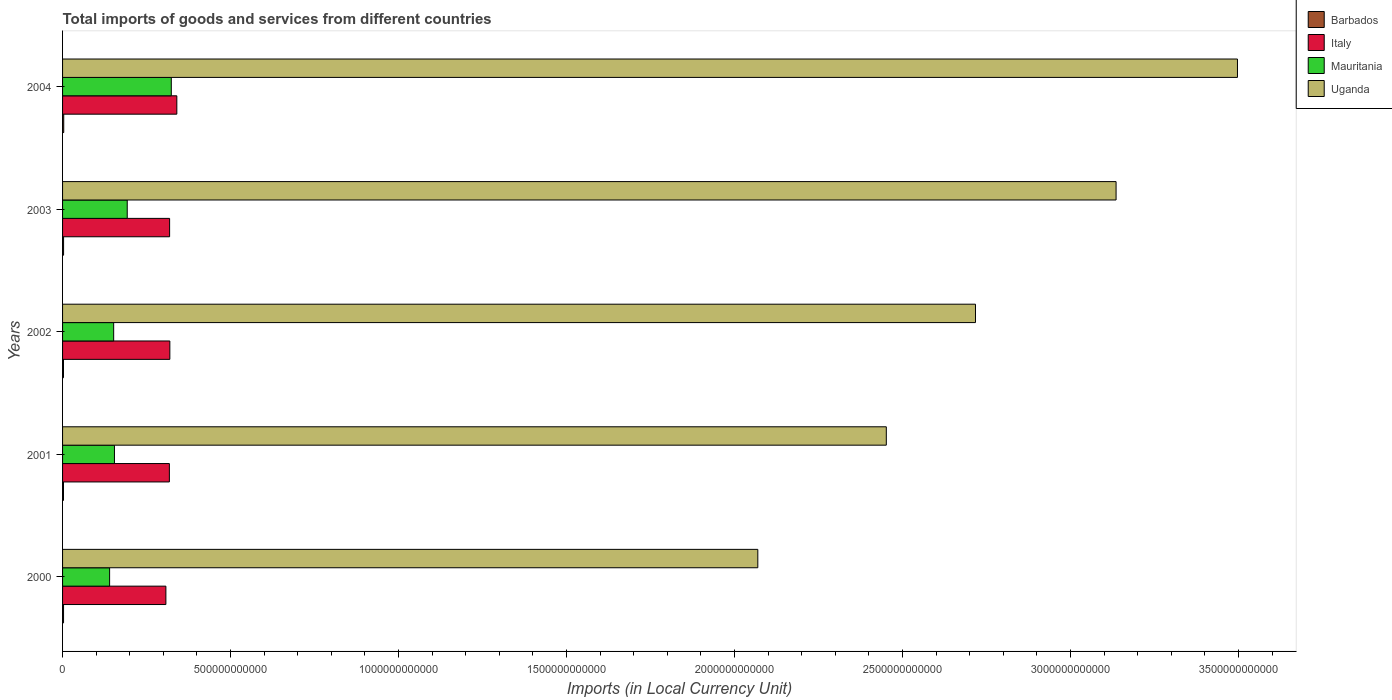Are the number of bars on each tick of the Y-axis equal?
Offer a very short reply. Yes. How many bars are there on the 3rd tick from the top?
Your response must be concise. 4. How many bars are there on the 5th tick from the bottom?
Your response must be concise. 4. What is the Amount of goods and services imports in Mauritania in 2004?
Ensure brevity in your answer.  3.24e+11. Across all years, what is the maximum Amount of goods and services imports in Italy?
Keep it short and to the point. 3.40e+11. Across all years, what is the minimum Amount of goods and services imports in Uganda?
Your answer should be very brief. 2.07e+12. In which year was the Amount of goods and services imports in Uganda minimum?
Provide a succinct answer. 2000. What is the total Amount of goods and services imports in Mauritania in the graph?
Ensure brevity in your answer.  9.63e+11. What is the difference between the Amount of goods and services imports in Mauritania in 2003 and that in 2004?
Provide a short and direct response. -1.31e+11. What is the difference between the Amount of goods and services imports in Barbados in 2004 and the Amount of goods and services imports in Mauritania in 2001?
Offer a terse response. -1.51e+11. What is the average Amount of goods and services imports in Uganda per year?
Offer a terse response. 2.77e+12. In the year 2001, what is the difference between the Amount of goods and services imports in Barbados and Amount of goods and services imports in Italy?
Ensure brevity in your answer.  -3.15e+11. What is the ratio of the Amount of goods and services imports in Uganda in 2002 to that in 2004?
Provide a short and direct response. 0.78. Is the difference between the Amount of goods and services imports in Barbados in 2002 and 2003 greater than the difference between the Amount of goods and services imports in Italy in 2002 and 2003?
Your response must be concise. No. What is the difference between the highest and the second highest Amount of goods and services imports in Mauritania?
Your answer should be compact. 1.31e+11. What is the difference between the highest and the lowest Amount of goods and services imports in Uganda?
Your answer should be compact. 1.43e+12. What does the 4th bar from the top in 2001 represents?
Your answer should be very brief. Barbados. What does the 1st bar from the bottom in 2000 represents?
Your answer should be compact. Barbados. How many years are there in the graph?
Offer a very short reply. 5. What is the difference between two consecutive major ticks on the X-axis?
Keep it short and to the point. 5.00e+11. Does the graph contain any zero values?
Your response must be concise. No. How are the legend labels stacked?
Your answer should be compact. Vertical. What is the title of the graph?
Keep it short and to the point. Total imports of goods and services from different countries. What is the label or title of the X-axis?
Keep it short and to the point. Imports (in Local Currency Unit). What is the Imports (in Local Currency Unit) of Barbados in 2000?
Offer a terse response. 2.90e+09. What is the Imports (in Local Currency Unit) in Italy in 2000?
Ensure brevity in your answer.  3.08e+11. What is the Imports (in Local Currency Unit) in Mauritania in 2000?
Your answer should be compact. 1.40e+11. What is the Imports (in Local Currency Unit) in Uganda in 2000?
Offer a very short reply. 2.07e+12. What is the Imports (in Local Currency Unit) in Barbados in 2001?
Offer a terse response. 2.77e+09. What is the Imports (in Local Currency Unit) of Italy in 2001?
Give a very brief answer. 3.18e+11. What is the Imports (in Local Currency Unit) in Mauritania in 2001?
Offer a very short reply. 1.54e+11. What is the Imports (in Local Currency Unit) in Uganda in 2001?
Your answer should be compact. 2.45e+12. What is the Imports (in Local Currency Unit) of Barbados in 2002?
Offer a terse response. 2.76e+09. What is the Imports (in Local Currency Unit) in Italy in 2002?
Make the answer very short. 3.19e+11. What is the Imports (in Local Currency Unit) in Mauritania in 2002?
Keep it short and to the point. 1.52e+11. What is the Imports (in Local Currency Unit) of Uganda in 2002?
Ensure brevity in your answer.  2.72e+12. What is the Imports (in Local Currency Unit) in Barbados in 2003?
Keep it short and to the point. 3.03e+09. What is the Imports (in Local Currency Unit) of Italy in 2003?
Your response must be concise. 3.19e+11. What is the Imports (in Local Currency Unit) of Mauritania in 2003?
Give a very brief answer. 1.92e+11. What is the Imports (in Local Currency Unit) of Uganda in 2003?
Ensure brevity in your answer.  3.14e+12. What is the Imports (in Local Currency Unit) of Barbados in 2004?
Give a very brief answer. 3.47e+09. What is the Imports (in Local Currency Unit) in Italy in 2004?
Keep it short and to the point. 3.40e+11. What is the Imports (in Local Currency Unit) of Mauritania in 2004?
Provide a short and direct response. 3.24e+11. What is the Imports (in Local Currency Unit) of Uganda in 2004?
Your answer should be compact. 3.50e+12. Across all years, what is the maximum Imports (in Local Currency Unit) of Barbados?
Offer a very short reply. 3.47e+09. Across all years, what is the maximum Imports (in Local Currency Unit) in Italy?
Your response must be concise. 3.40e+11. Across all years, what is the maximum Imports (in Local Currency Unit) in Mauritania?
Give a very brief answer. 3.24e+11. Across all years, what is the maximum Imports (in Local Currency Unit) in Uganda?
Make the answer very short. 3.50e+12. Across all years, what is the minimum Imports (in Local Currency Unit) of Barbados?
Your answer should be compact. 2.76e+09. Across all years, what is the minimum Imports (in Local Currency Unit) in Italy?
Provide a short and direct response. 3.08e+11. Across all years, what is the minimum Imports (in Local Currency Unit) of Mauritania?
Offer a very short reply. 1.40e+11. Across all years, what is the minimum Imports (in Local Currency Unit) of Uganda?
Offer a terse response. 2.07e+12. What is the total Imports (in Local Currency Unit) of Barbados in the graph?
Provide a short and direct response. 1.49e+1. What is the total Imports (in Local Currency Unit) of Italy in the graph?
Your response must be concise. 1.60e+12. What is the total Imports (in Local Currency Unit) in Mauritania in the graph?
Make the answer very short. 9.63e+11. What is the total Imports (in Local Currency Unit) in Uganda in the graph?
Keep it short and to the point. 1.39e+13. What is the difference between the Imports (in Local Currency Unit) of Barbados in 2000 and that in 2001?
Offer a terse response. 1.24e+08. What is the difference between the Imports (in Local Currency Unit) in Italy in 2000 and that in 2001?
Keep it short and to the point. -1.04e+1. What is the difference between the Imports (in Local Currency Unit) in Mauritania in 2000 and that in 2001?
Make the answer very short. -1.44e+1. What is the difference between the Imports (in Local Currency Unit) in Uganda in 2000 and that in 2001?
Your answer should be very brief. -3.82e+11. What is the difference between the Imports (in Local Currency Unit) of Barbados in 2000 and that in 2002?
Give a very brief answer. 1.33e+08. What is the difference between the Imports (in Local Currency Unit) of Italy in 2000 and that in 2002?
Your answer should be compact. -1.18e+1. What is the difference between the Imports (in Local Currency Unit) of Mauritania in 2000 and that in 2002?
Give a very brief answer. -1.21e+1. What is the difference between the Imports (in Local Currency Unit) of Uganda in 2000 and that in 2002?
Ensure brevity in your answer.  -6.48e+11. What is the difference between the Imports (in Local Currency Unit) in Barbados in 2000 and that in 2003?
Provide a succinct answer. -1.29e+08. What is the difference between the Imports (in Local Currency Unit) in Italy in 2000 and that in 2003?
Provide a short and direct response. -1.10e+1. What is the difference between the Imports (in Local Currency Unit) of Mauritania in 2000 and that in 2003?
Provide a short and direct response. -5.24e+1. What is the difference between the Imports (in Local Currency Unit) of Uganda in 2000 and that in 2003?
Ensure brevity in your answer.  -1.07e+12. What is the difference between the Imports (in Local Currency Unit) in Barbados in 2000 and that in 2004?
Give a very brief answer. -5.72e+08. What is the difference between the Imports (in Local Currency Unit) in Italy in 2000 and that in 2004?
Keep it short and to the point. -3.25e+1. What is the difference between the Imports (in Local Currency Unit) in Mauritania in 2000 and that in 2004?
Keep it short and to the point. -1.84e+11. What is the difference between the Imports (in Local Currency Unit) of Uganda in 2000 and that in 2004?
Offer a terse response. -1.43e+12. What is the difference between the Imports (in Local Currency Unit) of Barbados in 2001 and that in 2002?
Your response must be concise. 9.00e+06. What is the difference between the Imports (in Local Currency Unit) in Italy in 2001 and that in 2002?
Your response must be concise. -1.38e+09. What is the difference between the Imports (in Local Currency Unit) of Mauritania in 2001 and that in 2002?
Provide a succinct answer. 2.31e+09. What is the difference between the Imports (in Local Currency Unit) in Uganda in 2001 and that in 2002?
Your answer should be very brief. -2.65e+11. What is the difference between the Imports (in Local Currency Unit) in Barbados in 2001 and that in 2003?
Offer a terse response. -2.53e+08. What is the difference between the Imports (in Local Currency Unit) of Italy in 2001 and that in 2003?
Keep it short and to the point. -6.60e+08. What is the difference between the Imports (in Local Currency Unit) of Mauritania in 2001 and that in 2003?
Make the answer very short. -3.80e+1. What is the difference between the Imports (in Local Currency Unit) of Uganda in 2001 and that in 2003?
Provide a succinct answer. -6.84e+11. What is the difference between the Imports (in Local Currency Unit) of Barbados in 2001 and that in 2004?
Your response must be concise. -6.96e+08. What is the difference between the Imports (in Local Currency Unit) in Italy in 2001 and that in 2004?
Give a very brief answer. -2.22e+1. What is the difference between the Imports (in Local Currency Unit) of Mauritania in 2001 and that in 2004?
Offer a very short reply. -1.69e+11. What is the difference between the Imports (in Local Currency Unit) in Uganda in 2001 and that in 2004?
Provide a succinct answer. -1.05e+12. What is the difference between the Imports (in Local Currency Unit) in Barbados in 2002 and that in 2003?
Provide a succinct answer. -2.62e+08. What is the difference between the Imports (in Local Currency Unit) of Italy in 2002 and that in 2003?
Your answer should be compact. 7.24e+08. What is the difference between the Imports (in Local Currency Unit) of Mauritania in 2002 and that in 2003?
Provide a succinct answer. -4.03e+1. What is the difference between the Imports (in Local Currency Unit) of Uganda in 2002 and that in 2003?
Offer a very short reply. -4.18e+11. What is the difference between the Imports (in Local Currency Unit) in Barbados in 2002 and that in 2004?
Provide a succinct answer. -7.05e+08. What is the difference between the Imports (in Local Currency Unit) of Italy in 2002 and that in 2004?
Your answer should be compact. -2.08e+1. What is the difference between the Imports (in Local Currency Unit) in Mauritania in 2002 and that in 2004?
Make the answer very short. -1.72e+11. What is the difference between the Imports (in Local Currency Unit) of Uganda in 2002 and that in 2004?
Offer a terse response. -7.80e+11. What is the difference between the Imports (in Local Currency Unit) in Barbados in 2003 and that in 2004?
Offer a very short reply. -4.43e+08. What is the difference between the Imports (in Local Currency Unit) of Italy in 2003 and that in 2004?
Ensure brevity in your answer.  -2.15e+1. What is the difference between the Imports (in Local Currency Unit) of Mauritania in 2003 and that in 2004?
Your answer should be very brief. -1.31e+11. What is the difference between the Imports (in Local Currency Unit) of Uganda in 2003 and that in 2004?
Your answer should be very brief. -3.61e+11. What is the difference between the Imports (in Local Currency Unit) in Barbados in 2000 and the Imports (in Local Currency Unit) in Italy in 2001?
Provide a short and direct response. -3.15e+11. What is the difference between the Imports (in Local Currency Unit) in Barbados in 2000 and the Imports (in Local Currency Unit) in Mauritania in 2001?
Your answer should be compact. -1.52e+11. What is the difference between the Imports (in Local Currency Unit) in Barbados in 2000 and the Imports (in Local Currency Unit) in Uganda in 2001?
Provide a short and direct response. -2.45e+12. What is the difference between the Imports (in Local Currency Unit) of Italy in 2000 and the Imports (in Local Currency Unit) of Mauritania in 2001?
Your answer should be very brief. 1.53e+11. What is the difference between the Imports (in Local Currency Unit) of Italy in 2000 and the Imports (in Local Currency Unit) of Uganda in 2001?
Offer a terse response. -2.14e+12. What is the difference between the Imports (in Local Currency Unit) in Mauritania in 2000 and the Imports (in Local Currency Unit) in Uganda in 2001?
Give a very brief answer. -2.31e+12. What is the difference between the Imports (in Local Currency Unit) of Barbados in 2000 and the Imports (in Local Currency Unit) of Italy in 2002?
Offer a very short reply. -3.16e+11. What is the difference between the Imports (in Local Currency Unit) of Barbados in 2000 and the Imports (in Local Currency Unit) of Mauritania in 2002?
Your answer should be very brief. -1.49e+11. What is the difference between the Imports (in Local Currency Unit) in Barbados in 2000 and the Imports (in Local Currency Unit) in Uganda in 2002?
Provide a succinct answer. -2.71e+12. What is the difference between the Imports (in Local Currency Unit) of Italy in 2000 and the Imports (in Local Currency Unit) of Mauritania in 2002?
Your answer should be very brief. 1.55e+11. What is the difference between the Imports (in Local Currency Unit) in Italy in 2000 and the Imports (in Local Currency Unit) in Uganda in 2002?
Your response must be concise. -2.41e+12. What is the difference between the Imports (in Local Currency Unit) of Mauritania in 2000 and the Imports (in Local Currency Unit) of Uganda in 2002?
Offer a very short reply. -2.58e+12. What is the difference between the Imports (in Local Currency Unit) of Barbados in 2000 and the Imports (in Local Currency Unit) of Italy in 2003?
Make the answer very short. -3.16e+11. What is the difference between the Imports (in Local Currency Unit) in Barbados in 2000 and the Imports (in Local Currency Unit) in Mauritania in 2003?
Your answer should be very brief. -1.90e+11. What is the difference between the Imports (in Local Currency Unit) of Barbados in 2000 and the Imports (in Local Currency Unit) of Uganda in 2003?
Keep it short and to the point. -3.13e+12. What is the difference between the Imports (in Local Currency Unit) in Italy in 2000 and the Imports (in Local Currency Unit) in Mauritania in 2003?
Ensure brevity in your answer.  1.15e+11. What is the difference between the Imports (in Local Currency Unit) in Italy in 2000 and the Imports (in Local Currency Unit) in Uganda in 2003?
Keep it short and to the point. -2.83e+12. What is the difference between the Imports (in Local Currency Unit) of Mauritania in 2000 and the Imports (in Local Currency Unit) of Uganda in 2003?
Ensure brevity in your answer.  -3.00e+12. What is the difference between the Imports (in Local Currency Unit) of Barbados in 2000 and the Imports (in Local Currency Unit) of Italy in 2004?
Your answer should be very brief. -3.37e+11. What is the difference between the Imports (in Local Currency Unit) of Barbados in 2000 and the Imports (in Local Currency Unit) of Mauritania in 2004?
Keep it short and to the point. -3.21e+11. What is the difference between the Imports (in Local Currency Unit) of Barbados in 2000 and the Imports (in Local Currency Unit) of Uganda in 2004?
Offer a terse response. -3.49e+12. What is the difference between the Imports (in Local Currency Unit) of Italy in 2000 and the Imports (in Local Currency Unit) of Mauritania in 2004?
Make the answer very short. -1.61e+1. What is the difference between the Imports (in Local Currency Unit) of Italy in 2000 and the Imports (in Local Currency Unit) of Uganda in 2004?
Keep it short and to the point. -3.19e+12. What is the difference between the Imports (in Local Currency Unit) of Mauritania in 2000 and the Imports (in Local Currency Unit) of Uganda in 2004?
Give a very brief answer. -3.36e+12. What is the difference between the Imports (in Local Currency Unit) in Barbados in 2001 and the Imports (in Local Currency Unit) in Italy in 2002?
Your answer should be very brief. -3.17e+11. What is the difference between the Imports (in Local Currency Unit) of Barbados in 2001 and the Imports (in Local Currency Unit) of Mauritania in 2002?
Your answer should be very brief. -1.49e+11. What is the difference between the Imports (in Local Currency Unit) of Barbados in 2001 and the Imports (in Local Currency Unit) of Uganda in 2002?
Provide a short and direct response. -2.71e+12. What is the difference between the Imports (in Local Currency Unit) of Italy in 2001 and the Imports (in Local Currency Unit) of Mauritania in 2002?
Provide a succinct answer. 1.66e+11. What is the difference between the Imports (in Local Currency Unit) in Italy in 2001 and the Imports (in Local Currency Unit) in Uganda in 2002?
Ensure brevity in your answer.  -2.40e+12. What is the difference between the Imports (in Local Currency Unit) of Mauritania in 2001 and the Imports (in Local Currency Unit) of Uganda in 2002?
Give a very brief answer. -2.56e+12. What is the difference between the Imports (in Local Currency Unit) in Barbados in 2001 and the Imports (in Local Currency Unit) in Italy in 2003?
Keep it short and to the point. -3.16e+11. What is the difference between the Imports (in Local Currency Unit) in Barbados in 2001 and the Imports (in Local Currency Unit) in Mauritania in 2003?
Your response must be concise. -1.90e+11. What is the difference between the Imports (in Local Currency Unit) of Barbados in 2001 and the Imports (in Local Currency Unit) of Uganda in 2003?
Ensure brevity in your answer.  -3.13e+12. What is the difference between the Imports (in Local Currency Unit) in Italy in 2001 and the Imports (in Local Currency Unit) in Mauritania in 2003?
Offer a very short reply. 1.25e+11. What is the difference between the Imports (in Local Currency Unit) in Italy in 2001 and the Imports (in Local Currency Unit) in Uganda in 2003?
Make the answer very short. -2.82e+12. What is the difference between the Imports (in Local Currency Unit) in Mauritania in 2001 and the Imports (in Local Currency Unit) in Uganda in 2003?
Offer a terse response. -2.98e+12. What is the difference between the Imports (in Local Currency Unit) in Barbados in 2001 and the Imports (in Local Currency Unit) in Italy in 2004?
Offer a very short reply. -3.37e+11. What is the difference between the Imports (in Local Currency Unit) of Barbados in 2001 and the Imports (in Local Currency Unit) of Mauritania in 2004?
Provide a succinct answer. -3.21e+11. What is the difference between the Imports (in Local Currency Unit) of Barbados in 2001 and the Imports (in Local Currency Unit) of Uganda in 2004?
Offer a very short reply. -3.49e+12. What is the difference between the Imports (in Local Currency Unit) of Italy in 2001 and the Imports (in Local Currency Unit) of Mauritania in 2004?
Provide a short and direct response. -5.71e+09. What is the difference between the Imports (in Local Currency Unit) of Italy in 2001 and the Imports (in Local Currency Unit) of Uganda in 2004?
Your response must be concise. -3.18e+12. What is the difference between the Imports (in Local Currency Unit) in Mauritania in 2001 and the Imports (in Local Currency Unit) in Uganda in 2004?
Provide a succinct answer. -3.34e+12. What is the difference between the Imports (in Local Currency Unit) in Barbados in 2002 and the Imports (in Local Currency Unit) in Italy in 2003?
Offer a terse response. -3.16e+11. What is the difference between the Imports (in Local Currency Unit) of Barbados in 2002 and the Imports (in Local Currency Unit) of Mauritania in 2003?
Make the answer very short. -1.90e+11. What is the difference between the Imports (in Local Currency Unit) of Barbados in 2002 and the Imports (in Local Currency Unit) of Uganda in 2003?
Ensure brevity in your answer.  -3.13e+12. What is the difference between the Imports (in Local Currency Unit) of Italy in 2002 and the Imports (in Local Currency Unit) of Mauritania in 2003?
Keep it short and to the point. 1.27e+11. What is the difference between the Imports (in Local Currency Unit) of Italy in 2002 and the Imports (in Local Currency Unit) of Uganda in 2003?
Ensure brevity in your answer.  -2.82e+12. What is the difference between the Imports (in Local Currency Unit) in Mauritania in 2002 and the Imports (in Local Currency Unit) in Uganda in 2003?
Your response must be concise. -2.98e+12. What is the difference between the Imports (in Local Currency Unit) of Barbados in 2002 and the Imports (in Local Currency Unit) of Italy in 2004?
Offer a terse response. -3.37e+11. What is the difference between the Imports (in Local Currency Unit) in Barbados in 2002 and the Imports (in Local Currency Unit) in Mauritania in 2004?
Offer a very short reply. -3.21e+11. What is the difference between the Imports (in Local Currency Unit) of Barbados in 2002 and the Imports (in Local Currency Unit) of Uganda in 2004?
Your response must be concise. -3.49e+12. What is the difference between the Imports (in Local Currency Unit) in Italy in 2002 and the Imports (in Local Currency Unit) in Mauritania in 2004?
Keep it short and to the point. -4.32e+09. What is the difference between the Imports (in Local Currency Unit) of Italy in 2002 and the Imports (in Local Currency Unit) of Uganda in 2004?
Provide a short and direct response. -3.18e+12. What is the difference between the Imports (in Local Currency Unit) of Mauritania in 2002 and the Imports (in Local Currency Unit) of Uganda in 2004?
Provide a succinct answer. -3.34e+12. What is the difference between the Imports (in Local Currency Unit) in Barbados in 2003 and the Imports (in Local Currency Unit) in Italy in 2004?
Make the answer very short. -3.37e+11. What is the difference between the Imports (in Local Currency Unit) of Barbados in 2003 and the Imports (in Local Currency Unit) of Mauritania in 2004?
Give a very brief answer. -3.21e+11. What is the difference between the Imports (in Local Currency Unit) in Barbados in 2003 and the Imports (in Local Currency Unit) in Uganda in 2004?
Provide a succinct answer. -3.49e+12. What is the difference between the Imports (in Local Currency Unit) in Italy in 2003 and the Imports (in Local Currency Unit) in Mauritania in 2004?
Your answer should be very brief. -5.05e+09. What is the difference between the Imports (in Local Currency Unit) of Italy in 2003 and the Imports (in Local Currency Unit) of Uganda in 2004?
Keep it short and to the point. -3.18e+12. What is the difference between the Imports (in Local Currency Unit) in Mauritania in 2003 and the Imports (in Local Currency Unit) in Uganda in 2004?
Keep it short and to the point. -3.30e+12. What is the average Imports (in Local Currency Unit) of Barbados per year?
Offer a very short reply. 2.99e+09. What is the average Imports (in Local Currency Unit) in Italy per year?
Make the answer very short. 3.21e+11. What is the average Imports (in Local Currency Unit) of Mauritania per year?
Provide a succinct answer. 1.93e+11. What is the average Imports (in Local Currency Unit) of Uganda per year?
Provide a succinct answer. 2.77e+12. In the year 2000, what is the difference between the Imports (in Local Currency Unit) in Barbados and Imports (in Local Currency Unit) in Italy?
Provide a succinct answer. -3.05e+11. In the year 2000, what is the difference between the Imports (in Local Currency Unit) of Barbados and Imports (in Local Currency Unit) of Mauritania?
Offer a terse response. -1.37e+11. In the year 2000, what is the difference between the Imports (in Local Currency Unit) in Barbados and Imports (in Local Currency Unit) in Uganda?
Your response must be concise. -2.07e+12. In the year 2000, what is the difference between the Imports (in Local Currency Unit) of Italy and Imports (in Local Currency Unit) of Mauritania?
Provide a short and direct response. 1.68e+11. In the year 2000, what is the difference between the Imports (in Local Currency Unit) in Italy and Imports (in Local Currency Unit) in Uganda?
Keep it short and to the point. -1.76e+12. In the year 2000, what is the difference between the Imports (in Local Currency Unit) of Mauritania and Imports (in Local Currency Unit) of Uganda?
Offer a terse response. -1.93e+12. In the year 2001, what is the difference between the Imports (in Local Currency Unit) in Barbados and Imports (in Local Currency Unit) in Italy?
Your answer should be compact. -3.15e+11. In the year 2001, what is the difference between the Imports (in Local Currency Unit) in Barbados and Imports (in Local Currency Unit) in Mauritania?
Your response must be concise. -1.52e+11. In the year 2001, what is the difference between the Imports (in Local Currency Unit) in Barbados and Imports (in Local Currency Unit) in Uganda?
Keep it short and to the point. -2.45e+12. In the year 2001, what is the difference between the Imports (in Local Currency Unit) of Italy and Imports (in Local Currency Unit) of Mauritania?
Your answer should be compact. 1.63e+11. In the year 2001, what is the difference between the Imports (in Local Currency Unit) of Italy and Imports (in Local Currency Unit) of Uganda?
Your answer should be very brief. -2.13e+12. In the year 2001, what is the difference between the Imports (in Local Currency Unit) of Mauritania and Imports (in Local Currency Unit) of Uganda?
Your answer should be compact. -2.30e+12. In the year 2002, what is the difference between the Imports (in Local Currency Unit) in Barbados and Imports (in Local Currency Unit) in Italy?
Your answer should be very brief. -3.17e+11. In the year 2002, what is the difference between the Imports (in Local Currency Unit) of Barbados and Imports (in Local Currency Unit) of Mauritania?
Offer a terse response. -1.49e+11. In the year 2002, what is the difference between the Imports (in Local Currency Unit) in Barbados and Imports (in Local Currency Unit) in Uganda?
Give a very brief answer. -2.71e+12. In the year 2002, what is the difference between the Imports (in Local Currency Unit) of Italy and Imports (in Local Currency Unit) of Mauritania?
Provide a short and direct response. 1.67e+11. In the year 2002, what is the difference between the Imports (in Local Currency Unit) in Italy and Imports (in Local Currency Unit) in Uganda?
Provide a short and direct response. -2.40e+12. In the year 2002, what is the difference between the Imports (in Local Currency Unit) of Mauritania and Imports (in Local Currency Unit) of Uganda?
Your answer should be compact. -2.57e+12. In the year 2003, what is the difference between the Imports (in Local Currency Unit) of Barbados and Imports (in Local Currency Unit) of Italy?
Offer a terse response. -3.16e+11. In the year 2003, what is the difference between the Imports (in Local Currency Unit) of Barbados and Imports (in Local Currency Unit) of Mauritania?
Your answer should be very brief. -1.89e+11. In the year 2003, what is the difference between the Imports (in Local Currency Unit) of Barbados and Imports (in Local Currency Unit) of Uganda?
Your answer should be very brief. -3.13e+12. In the year 2003, what is the difference between the Imports (in Local Currency Unit) of Italy and Imports (in Local Currency Unit) of Mauritania?
Provide a short and direct response. 1.26e+11. In the year 2003, what is the difference between the Imports (in Local Currency Unit) of Italy and Imports (in Local Currency Unit) of Uganda?
Make the answer very short. -2.82e+12. In the year 2003, what is the difference between the Imports (in Local Currency Unit) in Mauritania and Imports (in Local Currency Unit) in Uganda?
Your answer should be compact. -2.94e+12. In the year 2004, what is the difference between the Imports (in Local Currency Unit) of Barbados and Imports (in Local Currency Unit) of Italy?
Offer a terse response. -3.37e+11. In the year 2004, what is the difference between the Imports (in Local Currency Unit) in Barbados and Imports (in Local Currency Unit) in Mauritania?
Offer a terse response. -3.20e+11. In the year 2004, what is the difference between the Imports (in Local Currency Unit) of Barbados and Imports (in Local Currency Unit) of Uganda?
Provide a succinct answer. -3.49e+12. In the year 2004, what is the difference between the Imports (in Local Currency Unit) of Italy and Imports (in Local Currency Unit) of Mauritania?
Your response must be concise. 1.65e+1. In the year 2004, what is the difference between the Imports (in Local Currency Unit) in Italy and Imports (in Local Currency Unit) in Uganda?
Offer a very short reply. -3.16e+12. In the year 2004, what is the difference between the Imports (in Local Currency Unit) of Mauritania and Imports (in Local Currency Unit) of Uganda?
Provide a succinct answer. -3.17e+12. What is the ratio of the Imports (in Local Currency Unit) in Barbados in 2000 to that in 2001?
Your answer should be very brief. 1.04. What is the ratio of the Imports (in Local Currency Unit) in Italy in 2000 to that in 2001?
Your answer should be compact. 0.97. What is the ratio of the Imports (in Local Currency Unit) in Mauritania in 2000 to that in 2001?
Offer a very short reply. 0.91. What is the ratio of the Imports (in Local Currency Unit) in Uganda in 2000 to that in 2001?
Offer a very short reply. 0.84. What is the ratio of the Imports (in Local Currency Unit) of Barbados in 2000 to that in 2002?
Provide a succinct answer. 1.05. What is the ratio of the Imports (in Local Currency Unit) of Italy in 2000 to that in 2002?
Provide a short and direct response. 0.96. What is the ratio of the Imports (in Local Currency Unit) in Mauritania in 2000 to that in 2002?
Offer a terse response. 0.92. What is the ratio of the Imports (in Local Currency Unit) of Uganda in 2000 to that in 2002?
Provide a short and direct response. 0.76. What is the ratio of the Imports (in Local Currency Unit) in Barbados in 2000 to that in 2003?
Keep it short and to the point. 0.96. What is the ratio of the Imports (in Local Currency Unit) of Italy in 2000 to that in 2003?
Offer a very short reply. 0.97. What is the ratio of the Imports (in Local Currency Unit) of Mauritania in 2000 to that in 2003?
Keep it short and to the point. 0.73. What is the ratio of the Imports (in Local Currency Unit) of Uganda in 2000 to that in 2003?
Provide a short and direct response. 0.66. What is the ratio of the Imports (in Local Currency Unit) in Barbados in 2000 to that in 2004?
Ensure brevity in your answer.  0.84. What is the ratio of the Imports (in Local Currency Unit) in Italy in 2000 to that in 2004?
Give a very brief answer. 0.9. What is the ratio of the Imports (in Local Currency Unit) of Mauritania in 2000 to that in 2004?
Offer a terse response. 0.43. What is the ratio of the Imports (in Local Currency Unit) of Uganda in 2000 to that in 2004?
Your response must be concise. 0.59. What is the ratio of the Imports (in Local Currency Unit) of Barbados in 2001 to that in 2002?
Make the answer very short. 1. What is the ratio of the Imports (in Local Currency Unit) in Italy in 2001 to that in 2002?
Keep it short and to the point. 1. What is the ratio of the Imports (in Local Currency Unit) of Mauritania in 2001 to that in 2002?
Keep it short and to the point. 1.02. What is the ratio of the Imports (in Local Currency Unit) in Uganda in 2001 to that in 2002?
Give a very brief answer. 0.9. What is the ratio of the Imports (in Local Currency Unit) of Barbados in 2001 to that in 2003?
Your answer should be compact. 0.92. What is the ratio of the Imports (in Local Currency Unit) in Italy in 2001 to that in 2003?
Make the answer very short. 1. What is the ratio of the Imports (in Local Currency Unit) of Mauritania in 2001 to that in 2003?
Make the answer very short. 0.8. What is the ratio of the Imports (in Local Currency Unit) in Uganda in 2001 to that in 2003?
Give a very brief answer. 0.78. What is the ratio of the Imports (in Local Currency Unit) in Barbados in 2001 to that in 2004?
Your answer should be compact. 0.8. What is the ratio of the Imports (in Local Currency Unit) in Italy in 2001 to that in 2004?
Your response must be concise. 0.93. What is the ratio of the Imports (in Local Currency Unit) in Mauritania in 2001 to that in 2004?
Your response must be concise. 0.48. What is the ratio of the Imports (in Local Currency Unit) of Uganda in 2001 to that in 2004?
Ensure brevity in your answer.  0.7. What is the ratio of the Imports (in Local Currency Unit) in Barbados in 2002 to that in 2003?
Keep it short and to the point. 0.91. What is the ratio of the Imports (in Local Currency Unit) of Mauritania in 2002 to that in 2003?
Make the answer very short. 0.79. What is the ratio of the Imports (in Local Currency Unit) of Uganda in 2002 to that in 2003?
Provide a succinct answer. 0.87. What is the ratio of the Imports (in Local Currency Unit) of Barbados in 2002 to that in 2004?
Make the answer very short. 0.8. What is the ratio of the Imports (in Local Currency Unit) in Italy in 2002 to that in 2004?
Offer a very short reply. 0.94. What is the ratio of the Imports (in Local Currency Unit) of Mauritania in 2002 to that in 2004?
Offer a very short reply. 0.47. What is the ratio of the Imports (in Local Currency Unit) of Uganda in 2002 to that in 2004?
Give a very brief answer. 0.78. What is the ratio of the Imports (in Local Currency Unit) in Barbados in 2003 to that in 2004?
Provide a succinct answer. 0.87. What is the ratio of the Imports (in Local Currency Unit) in Italy in 2003 to that in 2004?
Give a very brief answer. 0.94. What is the ratio of the Imports (in Local Currency Unit) of Mauritania in 2003 to that in 2004?
Offer a very short reply. 0.59. What is the ratio of the Imports (in Local Currency Unit) of Uganda in 2003 to that in 2004?
Keep it short and to the point. 0.9. What is the difference between the highest and the second highest Imports (in Local Currency Unit) in Barbados?
Give a very brief answer. 4.43e+08. What is the difference between the highest and the second highest Imports (in Local Currency Unit) in Italy?
Make the answer very short. 2.08e+1. What is the difference between the highest and the second highest Imports (in Local Currency Unit) of Mauritania?
Your answer should be very brief. 1.31e+11. What is the difference between the highest and the second highest Imports (in Local Currency Unit) in Uganda?
Your answer should be very brief. 3.61e+11. What is the difference between the highest and the lowest Imports (in Local Currency Unit) in Barbados?
Your answer should be compact. 7.05e+08. What is the difference between the highest and the lowest Imports (in Local Currency Unit) in Italy?
Your answer should be compact. 3.25e+1. What is the difference between the highest and the lowest Imports (in Local Currency Unit) in Mauritania?
Keep it short and to the point. 1.84e+11. What is the difference between the highest and the lowest Imports (in Local Currency Unit) of Uganda?
Give a very brief answer. 1.43e+12. 